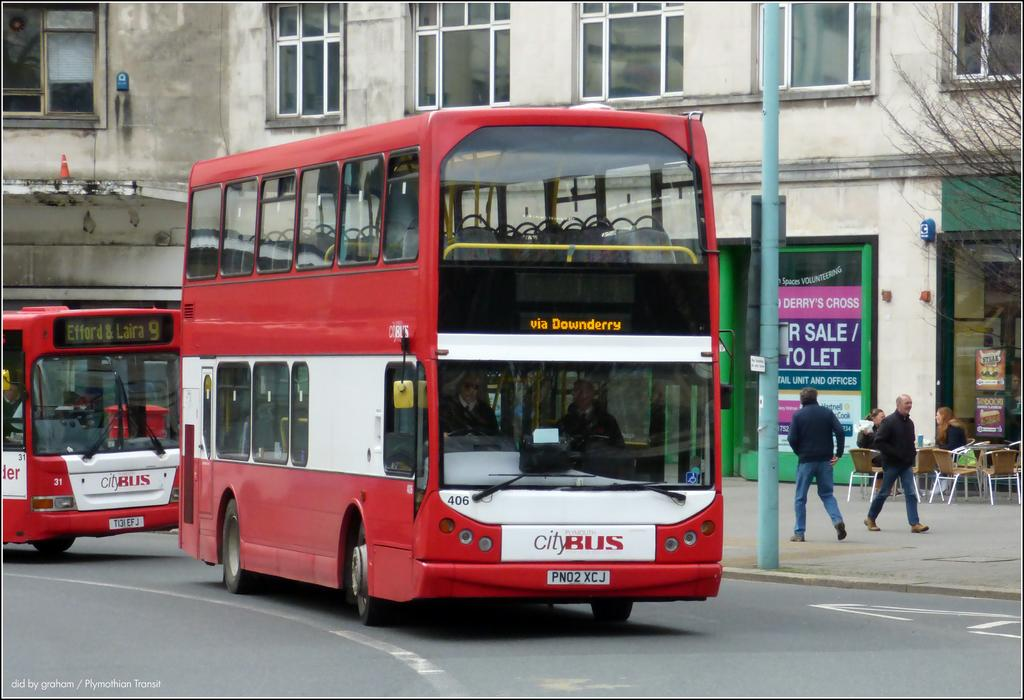<image>
Offer a succinct explanation of the picture presented. A red, double decker City Bus travels along via Downderry. 